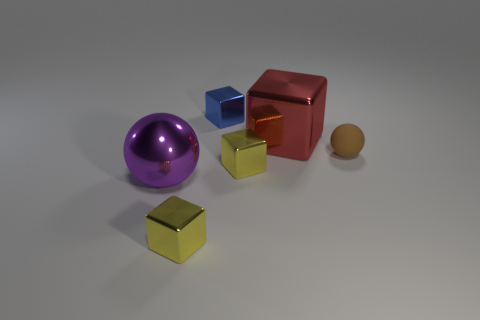Add 1 small gray cubes. How many objects exist? 7 Subtract all balls. How many objects are left? 4 Add 6 small matte spheres. How many small matte spheres exist? 7 Subtract 0 cyan cubes. How many objects are left? 6 Subtract all tiny blue shiny blocks. Subtract all shiny balls. How many objects are left? 4 Add 4 tiny blue shiny objects. How many tiny blue shiny objects are left? 5 